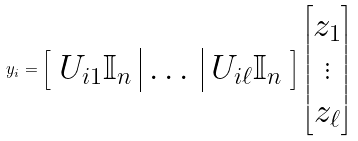Convert formula to latex. <formula><loc_0><loc_0><loc_500><loc_500>y _ { i } = \left [ \begin{array} { c | c | c } U _ { i 1 } \mathbb { I } _ { n } & \dots & U _ { i \ell } \mathbb { I } _ { n } \end{array} \right ] \begin{bmatrix} z _ { 1 } \\ \vdots \\ z _ { \ell } \end{bmatrix}</formula> 